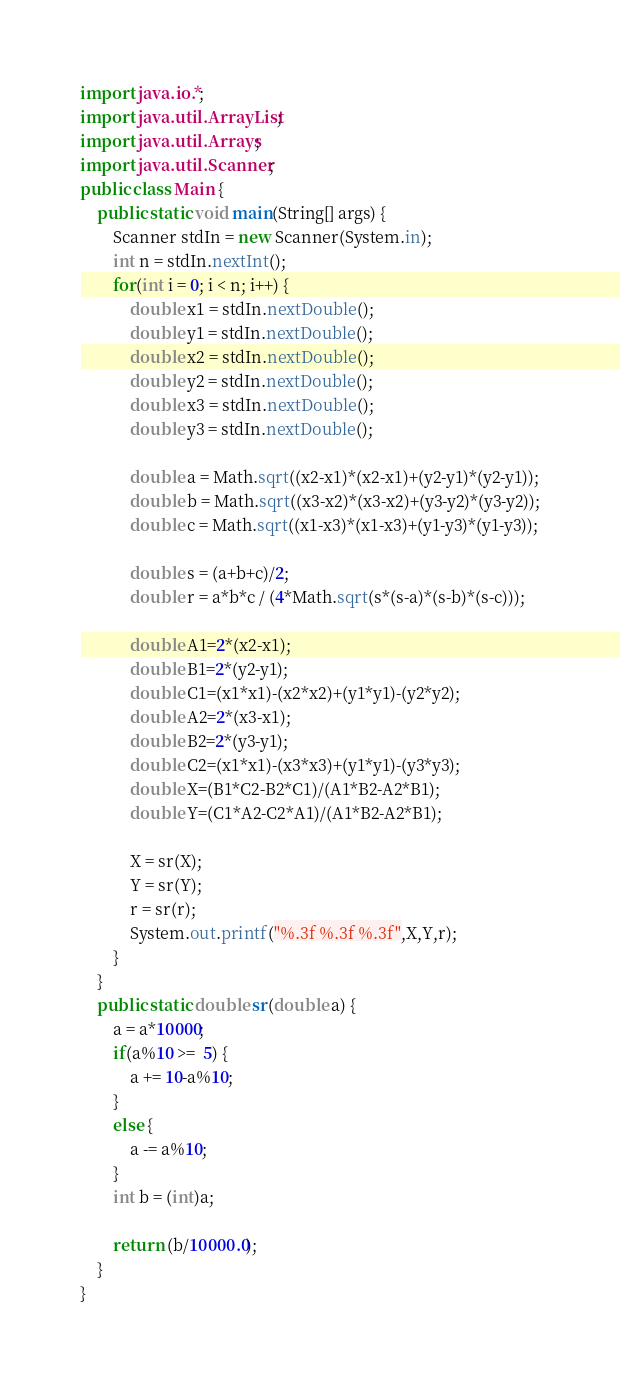<code> <loc_0><loc_0><loc_500><loc_500><_Java_>import java.io.*;
import java.util.ArrayList;
import java.util.Arrays;
import java.util.Scanner;
public class Main {
	public static void main(String[] args) {
		Scanner stdIn = new Scanner(System.in);
		int n = stdIn.nextInt();
		for(int i = 0; i < n; i++) {
			double x1 = stdIn.nextDouble();
			double y1 = stdIn.nextDouble();
			double x2 = stdIn.nextDouble();
			double y2 = stdIn.nextDouble();
			double x3 = stdIn.nextDouble();
			double y3 = stdIn.nextDouble();
			
			double a = Math.sqrt((x2-x1)*(x2-x1)+(y2-y1)*(y2-y1));
			double b = Math.sqrt((x3-x2)*(x3-x2)+(y3-y2)*(y3-y2));
			double c = Math.sqrt((x1-x3)*(x1-x3)+(y1-y3)*(y1-y3));
			
			double s = (a+b+c)/2;
			double r = a*b*c / (4*Math.sqrt(s*(s-a)*(s-b)*(s-c)));
			
			double A1=2*(x2-x1);
			double B1=2*(y2-y1);
			double C1=(x1*x1)-(x2*x2)+(y1*y1)-(y2*y2);
			double A2=2*(x3-x1);
			double B2=2*(y3-y1);
			double C2=(x1*x1)-(x3*x3)+(y1*y1)-(y3*y3);
			double X=(B1*C2-B2*C1)/(A1*B2-A2*B1);
			double Y=(C1*A2-C2*A1)/(A1*B2-A2*B1);
			
			X = sr(X);
			Y = sr(Y);
			r = sr(r);
			System.out.printf("%.3f %.3f %.3f",X,Y,r);
		}
	}
	public static double sr(double a) {
		a = a*10000;
		if(a%10 >=  5) {
			a += 10-a%10;
		}
		else {
			a -= a%10;
		}
		int b = (int)a;
		
		return (b/10000.0);
	}
}</code> 